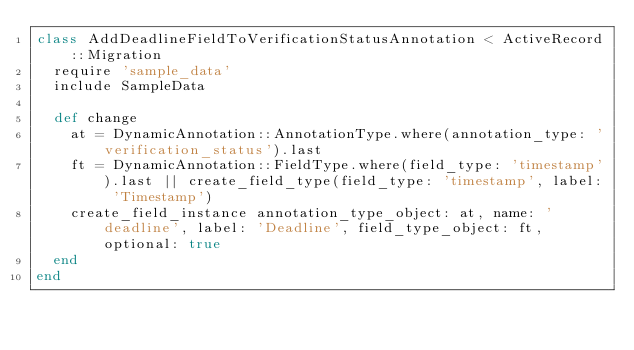<code> <loc_0><loc_0><loc_500><loc_500><_Ruby_>class AddDeadlineFieldToVerificationStatusAnnotation < ActiveRecord::Migration
  require 'sample_data'
  include SampleData

  def change
    at = DynamicAnnotation::AnnotationType.where(annotation_type: 'verification_status').last
    ft = DynamicAnnotation::FieldType.where(field_type: 'timestamp').last || create_field_type(field_type: 'timestamp', label: 'Timestamp')
    create_field_instance annotation_type_object: at, name: 'deadline', label: 'Deadline', field_type_object: ft, optional: true
  end
end
</code> 